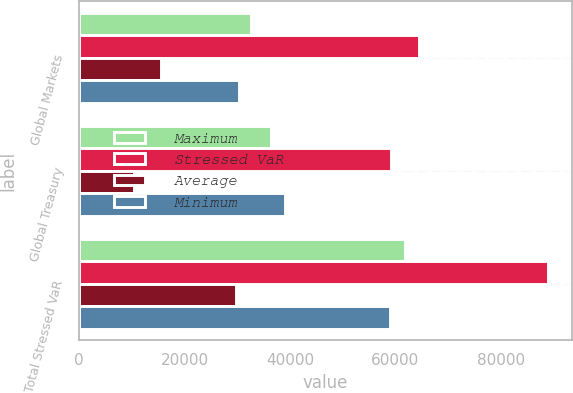<chart> <loc_0><loc_0><loc_500><loc_500><stacked_bar_chart><ecel><fcel>Global Markets<fcel>Global Treasury<fcel>Total Stressed VaR<nl><fcel>Maximum<fcel>32639<fcel>36344<fcel>61874<nl><fcel>Stressed VaR<fcel>64510<fcel>59253<fcel>89053<nl><fcel>Average<fcel>15625<fcel>10454<fcel>29689<nl><fcel>Minimum<fcel>30255<fcel>39050<fcel>58945<nl></chart> 